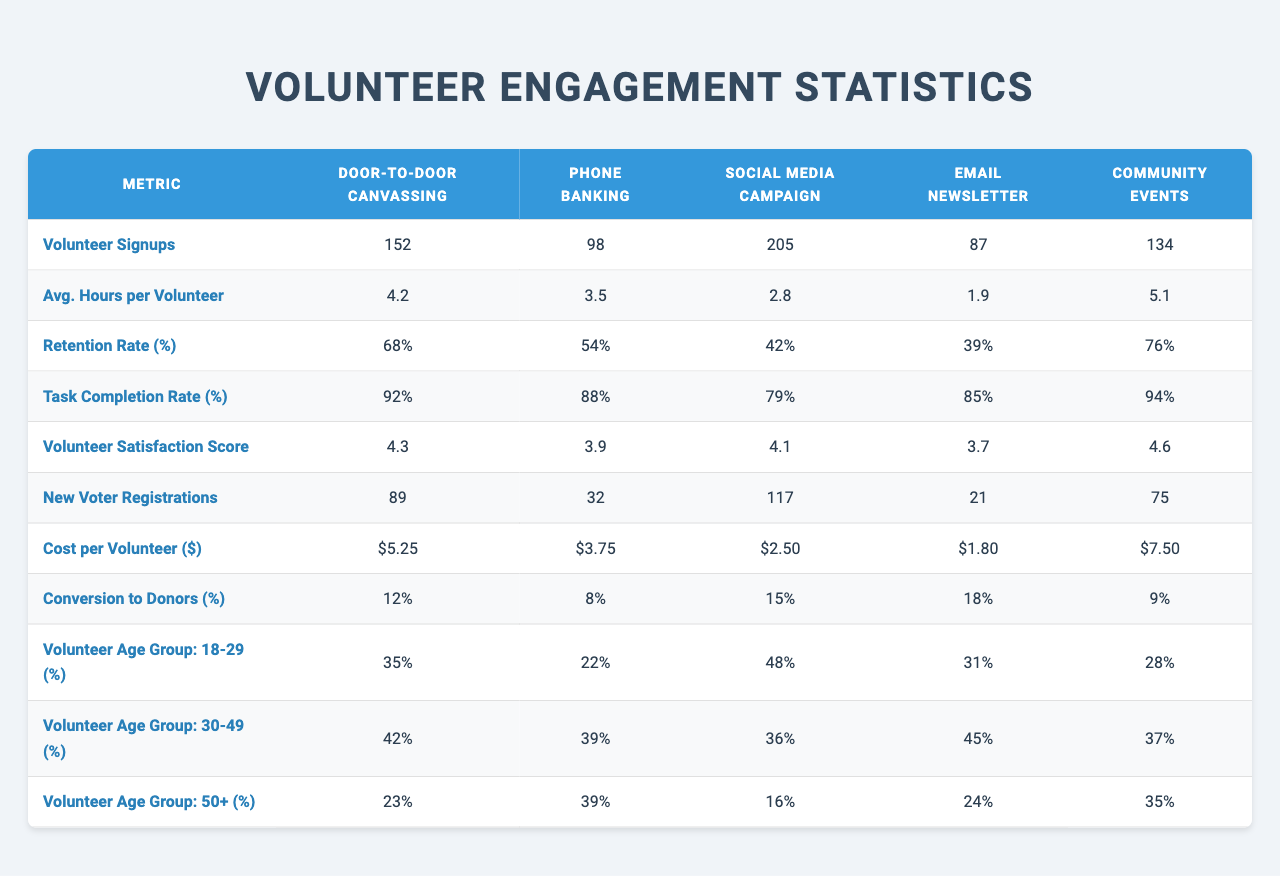What is the highest number of volunteer signups? The highest number of volunteer signups is found by comparing the values in the "Volunteer Signups" row. The values are 152, 98, 205, 87, and 134. The maximum is 205.
Answer: 205 Which outreach method has the lowest average hours per volunteer? To find the lowest average, look at the "Avg. Hours per Volunteer" row. The values are 4.2, 3.5, 2.8, 1.9, and 5.1. The minimum value is 1.9.
Answer: 1.9 What percentage of volunteers in phone banking are aged 50 and above? The percentage of volunteers aged 50 plus in phone banking can be found in the "Volunteer Age Group: 50+" row. The value corresponding to phone banking is 39%.
Answer: 39% Which outreach method had the highest retention rate percentage? Evaluate the "Retention Rate (%)" row for the highest value. The values are 68, 54, 42, 39, and 76. The maximum is 76, corresponding to community events.
Answer: 76 Calculate the average cost per volunteer across all outreach methods. The cost values are 5.25, 3.75, 2.50, 1.80, and 7.50. The sum is 20.80, and there are 5 outreach methods, so the average is 20.80/5 = 4.16.
Answer: 4.16 Is the satisfaction score for community events higher than for phone banking? The satisfaction scores are 4.6 for community events and 3.9 for phone banking. Since 4.6 is greater than 3.9, the answer is yes.
Answer: Yes Which outreach method had the most new voter registrations? To find this, look at the "New Voter Registrations" row. The values are 89, 32, 117, 21, and 75. The maximum is 117, for the social media campaign.
Answer: 117 What is the total volunteer signups from door-to-door canvassing and community events combined? Add the signups from door-to-door canvassing (152) and community events (134). The sum is 152 + 134 = 286.
Answer: 286 Which outreach method had the highest conversion to donors percentage? Compare the values in the "Conversion to Donors (%)" row: 12, 8, 15, 18, 9. The highest is 18% for the email newsletter.
Answer: 18 Calculate the difference in retention rates between the outreach methods with the highest and lowest rates. The highest retention rate is 76% (community events) and the lowest is 39% (email newsletter). The difference is 76 - 39 = 37%.
Answer: 37 What percentage of volunteers in social media campaigns are aged 30 to 49? For social media campaigns, the percentage aged 30 to 49 is found in the "Volunteer Age Group: 30-49 (%)" row, which shows 36%.
Answer: 36 